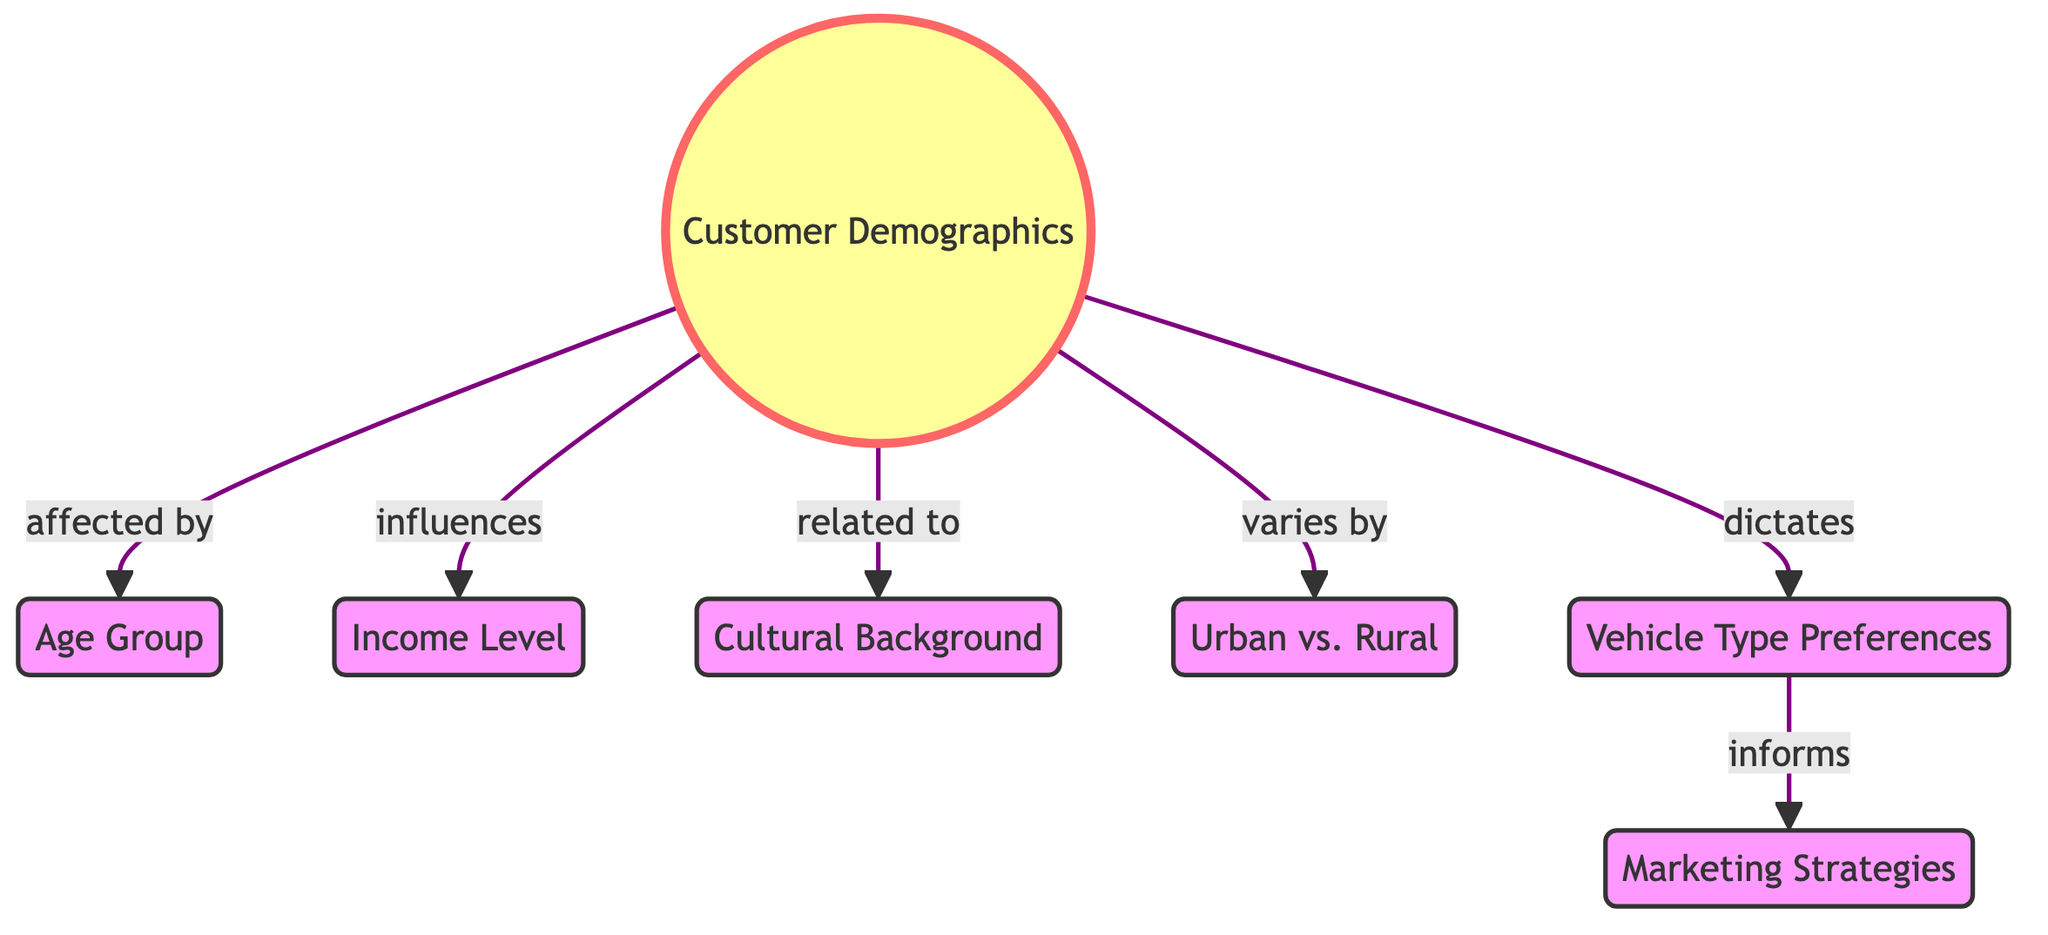What is the main node in the diagram? The main node in the diagram is "Customer Demographics," which is highlighted and serves as the central focus of the relationships illustrated in the flowchart.
Answer: Customer Demographics How many influencing factors are listed in the diagram? The diagram lists five influencing factors that connect to "Customer Demographics," which are Age Group, Income Level, Cultural Background, Urban vs. Rural, and Vehicle Type Preferences.
Answer: Five What does "Customer Demographics" affect? "Customer Demographics" affects "Age Group," indicating that customer demographics play a role in determining the age distribution of customers.
Answer: Age Group Which factor is influenced by "Marketing Strategies"? "Vehicle Type Preferences" influences "Marketing Strategies," suggesting that understanding the types of vehicles customers prefer will inform how marketing efforts are structured.
Answer: Vehicle Type Preferences What relationship does "Cultural Background" have with "Customer Demographics"? "Cultural Background" is related to "Customer Demographics," indicating that cultural factors can also define the characteristics of the customer base.
Answer: Related to Which node directly informs "Marketing Strategies"? "Vehicle Type Preferences" directly informs "Marketing Strategies," showing that preferences for different types of vehicles play a crucial role in shaping marketing efforts.
Answer: Vehicle Type Preferences How does "Age Group" influence "Income Level"? "Age Group" influences "Income Level," suggesting that different age segments may have varying income levels which can affect purchasing behavior and preferences for auto parts.
Answer: Influences Which two factors vary in relation to "Customer Demographics"? "Urban vs. Rural" and "Cultural Background" are the two factors that vary in relation to "Customer Demographics," indicating that these elements can change alongside the demographics of customers.
Answer: Urban vs. Rural, Cultural Background What is the significance of "Vehicle Type Preferences" in the diagram? "Vehicle Type Preferences" is significant because it dictates the marketing strategies employed, emphasizing its importance in customer interaction and sales approaches.
Answer: Dictates 